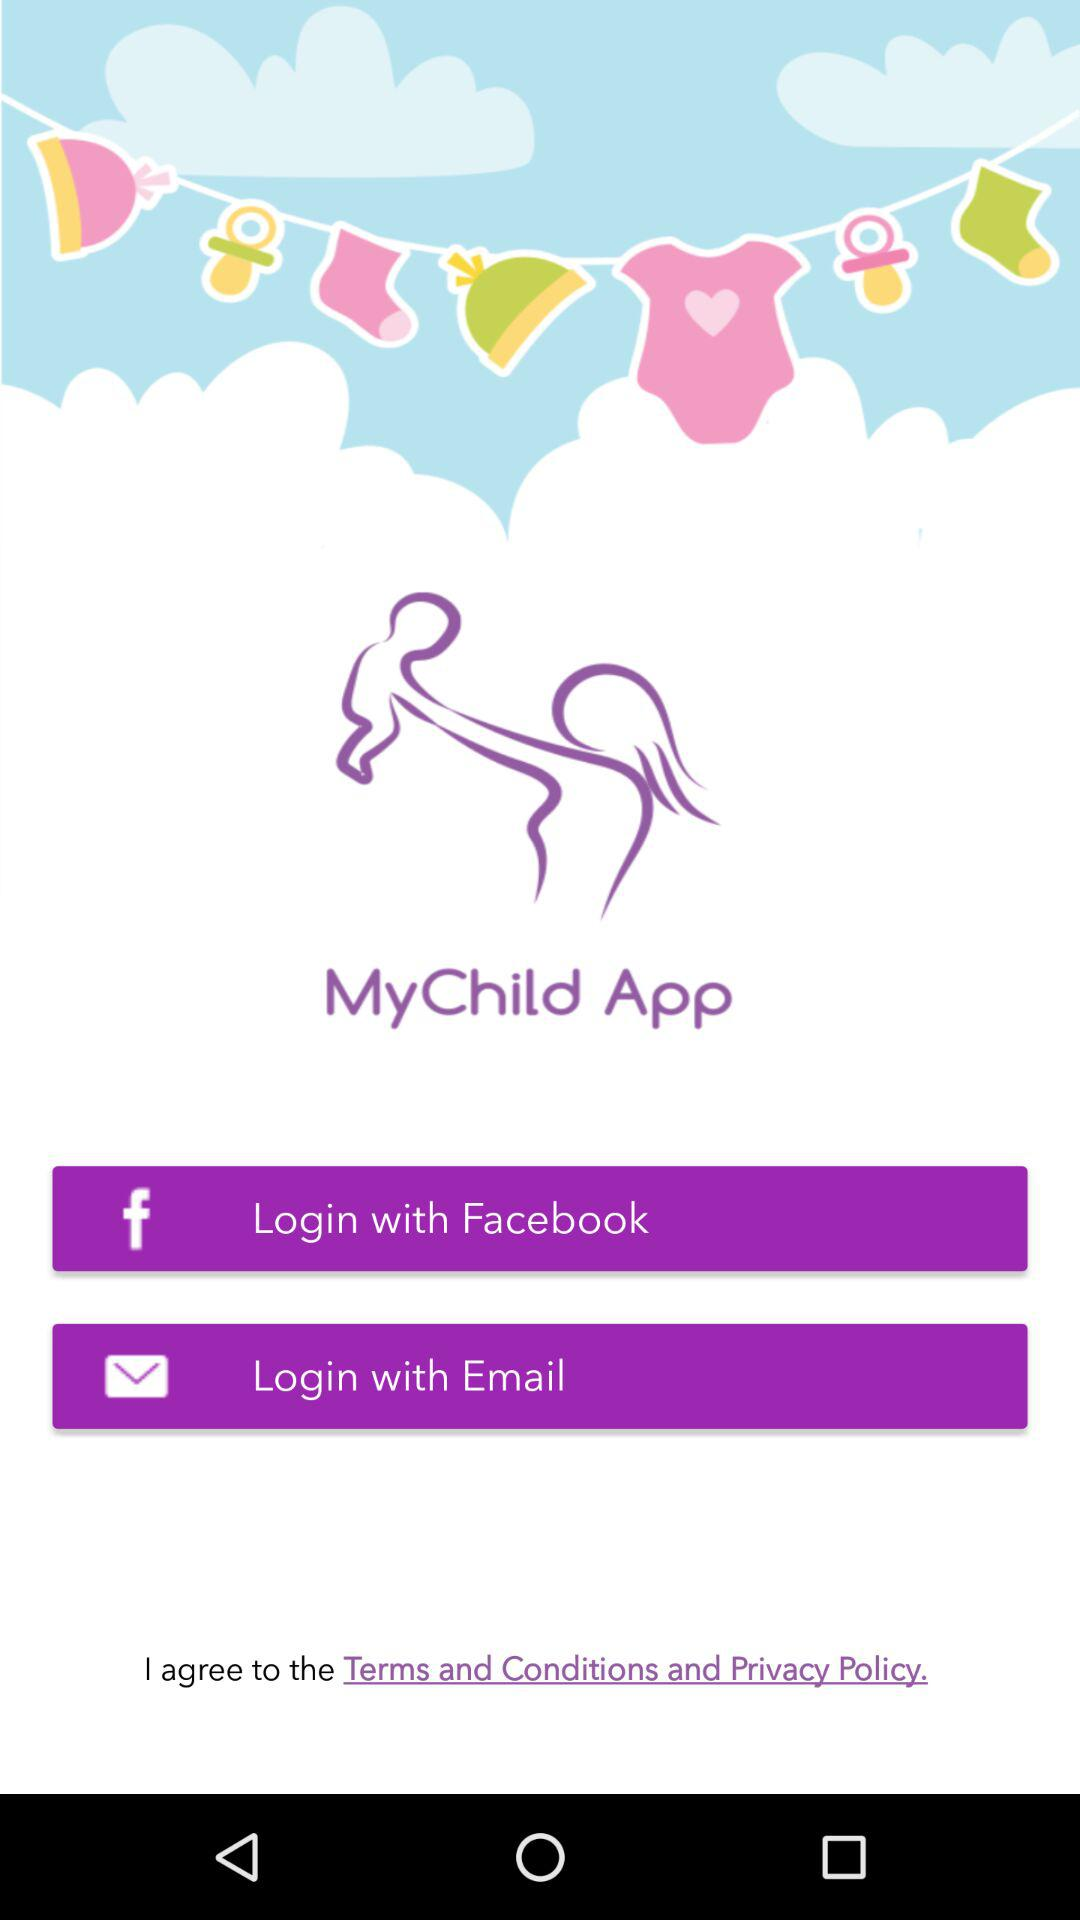How many login options are available to users?
Answer the question using a single word or phrase. 2 